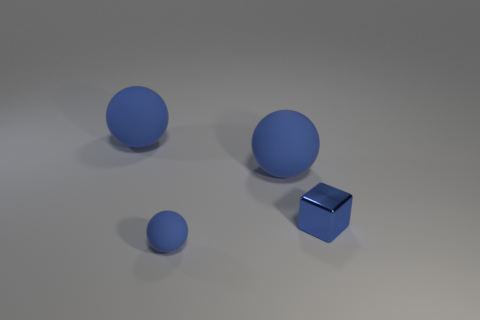How many things are blue things behind the tiny blue metal block or small blue metal things?
Provide a short and direct response. 3. Is the number of metal blocks that are to the right of the shiny object greater than the number of large blue objects on the right side of the small sphere?
Your answer should be compact. No. Does the tiny ball have the same material as the block?
Provide a short and direct response. No. The object that is behind the tiny blue shiny block and on the right side of the small matte object has what shape?
Offer a very short reply. Sphere. Is there a big purple matte object?
Keep it short and to the point. No. Are there any blue things that are behind the blue matte sphere that is in front of the small blue metal cube?
Make the answer very short. Yes. Is the number of small objects greater than the number of shiny things?
Provide a succinct answer. Yes. There is a tiny sphere; is its color the same as the large thing that is on the right side of the small ball?
Give a very brief answer. Yes. The thing that is both to the right of the tiny rubber sphere and on the left side of the small block is what color?
Your answer should be compact. Blue. How many other things are the same material as the tiny block?
Your answer should be very brief. 0. 